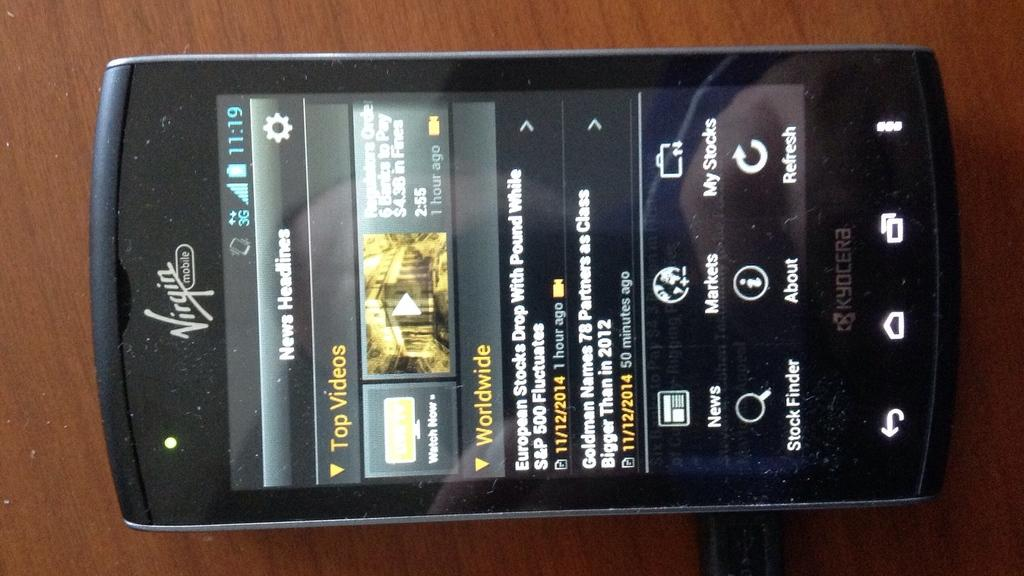Provide a one-sentence caption for the provided image. Virgin mobile cellphone that is showing worldwide videos. 